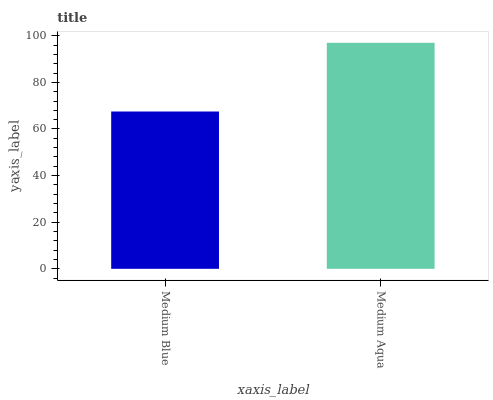Is Medium Blue the minimum?
Answer yes or no. Yes. Is Medium Aqua the maximum?
Answer yes or no. Yes. Is Medium Aqua the minimum?
Answer yes or no. No. Is Medium Aqua greater than Medium Blue?
Answer yes or no. Yes. Is Medium Blue less than Medium Aqua?
Answer yes or no. Yes. Is Medium Blue greater than Medium Aqua?
Answer yes or no. No. Is Medium Aqua less than Medium Blue?
Answer yes or no. No. Is Medium Aqua the high median?
Answer yes or no. Yes. Is Medium Blue the low median?
Answer yes or no. Yes. Is Medium Blue the high median?
Answer yes or no. No. Is Medium Aqua the low median?
Answer yes or no. No. 